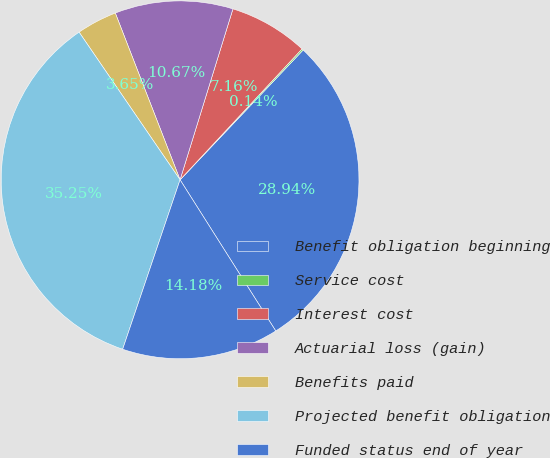<chart> <loc_0><loc_0><loc_500><loc_500><pie_chart><fcel>Benefit obligation beginning<fcel>Service cost<fcel>Interest cost<fcel>Actuarial loss (gain)<fcel>Benefits paid<fcel>Projected benefit obligation<fcel>Funded status end of year<nl><fcel>28.94%<fcel>0.14%<fcel>7.16%<fcel>10.67%<fcel>3.65%<fcel>35.25%<fcel>14.18%<nl></chart> 